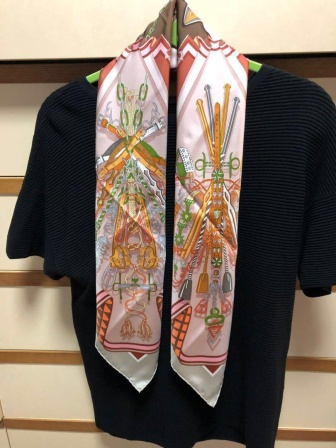If this scene were a part of a movie, what would the plot be? In the backdrop of a quaint, picturesque town, this scene unfolds as a part of a heartwarming film. The story revolves around Emma, a talented designer who moved from the bustling city to find inspiration and peace in the countryside. She frequents a local vintage shop where she discovers this black sweater and the vibrant scarf, each piece beckoning to her creative spirit. Emma decides to start a small clothing line inspired by her new surroundings, using the sweater and scarf as the cornerstone of her first collection. The film follows her journey of self-discovery, the friendships she forms, and the challenges she overcomes to pursue her dreams. The hanging sweater and scarf become a symbol of her new beginning and her passion for creating beauty from simplicity. 